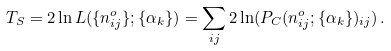Convert formula to latex. <formula><loc_0><loc_0><loc_500><loc_500>T _ { S } = 2 \ln L ( \{ n _ { i j } ^ { o } \} ; \{ \alpha _ { k } \} ) = \sum _ { i j } 2 \ln ( P _ { C } ( n _ { i j } ^ { o } ; \{ \alpha _ { k } \} ) _ { i j } ) \, .</formula> 